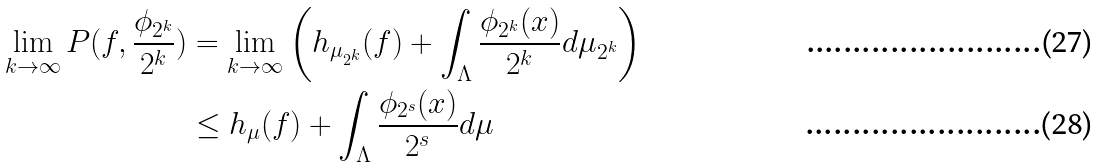<formula> <loc_0><loc_0><loc_500><loc_500>\lim _ { k \rightarrow \infty } P ( f , \frac { \phi _ { 2 ^ { k } } } { 2 ^ { k } } ) & = \lim _ { k \rightarrow \infty } \left ( h _ { \mu _ { 2 ^ { k } } } ( f ) + \int _ { \Lambda } \frac { \phi _ { 2 ^ { k } } ( x ) } { 2 ^ { k } } d \mu _ { 2 ^ { k } } \right ) \\ & \leq h _ { \mu } ( f ) + \int _ { \Lambda } \frac { \phi _ { 2 ^ { s } } ( x ) } { 2 ^ { s } } d \mu</formula> 